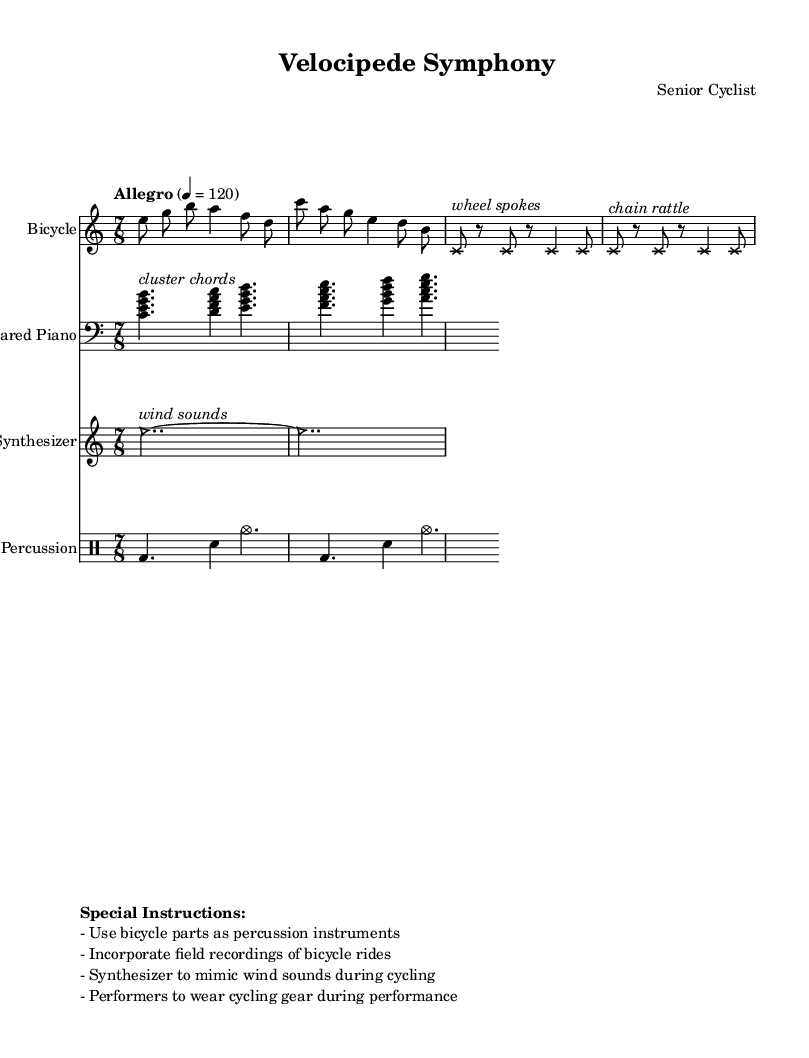What is the time signature of this music? The time signature is indicated at the beginning of the main theme where it shows 7/8, which represents a compound time signature with seven eighth notes.
Answer: 7/8 What instruments are featured in the composition? The composition features four distinct parts, which include a Bicycle, Prepared Piano, Synthesizer, and Percussion. Each part is labeled at the beginning of its staff.
Answer: Bicycle, Prepared Piano, Synthesizer, Percussion What is the tempo marking for the piece? The tempo marking is found above the main theme, indicating "Allegro" at a speed of 120 beats per minute (4 = 120).
Answer: Allegro, 120 How are bicycle sounds represented in the score? Bicycle sounds are represented in the score by notes with a cross note head and accompanying textual descriptions, specifying them as "wheel spokes" and "chain rattle."
Answer: By cross note heads with text labels What special instructions are given for the performance? The special instructions are provided at the end of the score, indicating that performers should use bicycle parts as percussion, incorporate field recordings, mimic wind sounds with the synthesizer, and wear cycling gear.
Answer: Performers to use bicycle parts, field recordings, mimic wind sounds, wear cycling gear Which section of the music incorporates synthesizer sounds? The synth sounds are found in the staff labeled "Synthesizer," where the notes have a triangle note head and are combined with the text "wind sounds" to describe their character.
Answer: Synthesizer section 